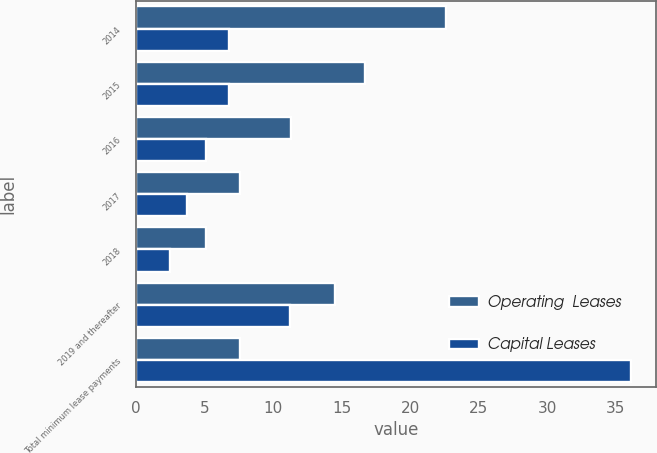Convert chart. <chart><loc_0><loc_0><loc_500><loc_500><stacked_bar_chart><ecel><fcel>2014<fcel>2015<fcel>2016<fcel>2017<fcel>2018<fcel>2019 and thereafter<fcel>Total minimum lease payments<nl><fcel>Operating  Leases<fcel>22.6<fcel>16.7<fcel>11.3<fcel>7.6<fcel>5.1<fcel>14.5<fcel>7.6<nl><fcel>Capital Leases<fcel>6.8<fcel>6.8<fcel>5.1<fcel>3.7<fcel>2.5<fcel>11.2<fcel>36.1<nl></chart> 